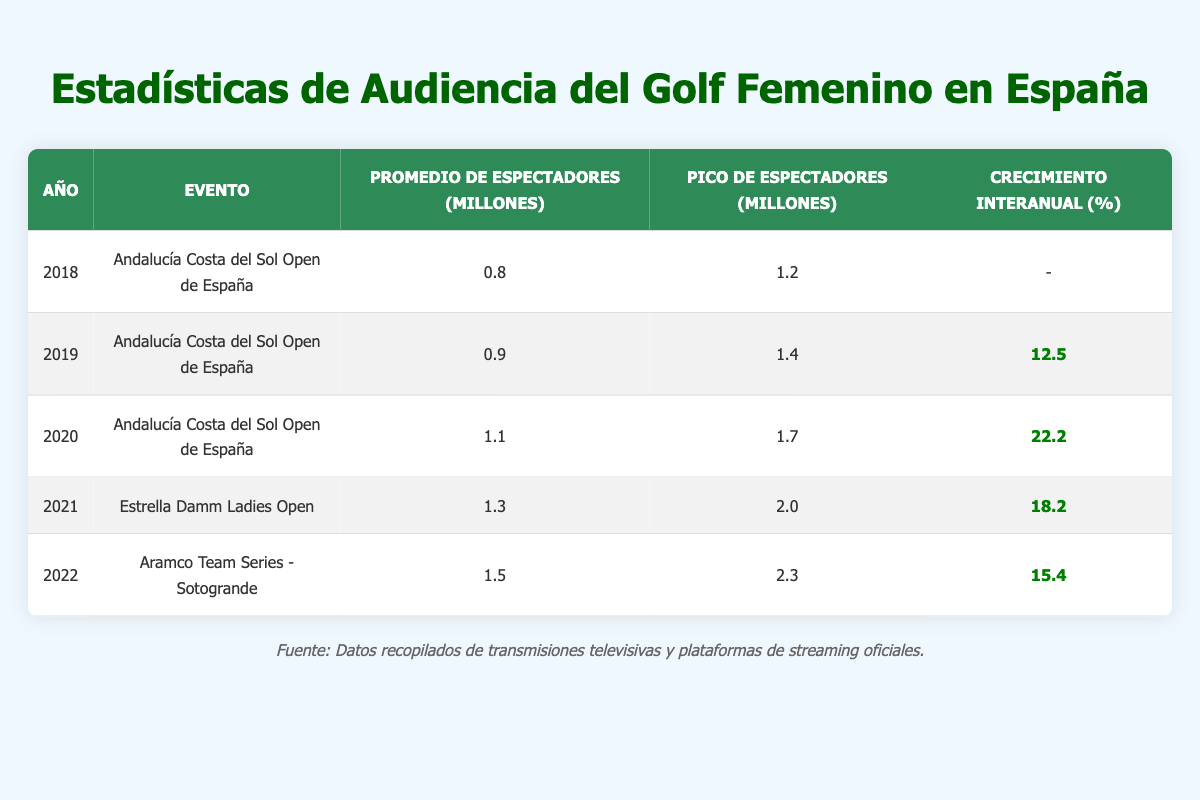What was the average viewership in 2022? The table shows that in 2022, the average viewers for the "Aramco Team Series - Sotogrande" was 1.5 million.
Answer: 1.5 million In which year did the "Estrella Damm Ladies Open" take place? According to the table, the "Estrella Damm Ladies Open" was held in 2021.
Answer: 2021 What was the year-on-year growth between 2020 and 2021? For 2020, the average viewers were 1.1 million and for 2021, it was 1.3 million. The year-on-year growth can be calculated as ((1.3 - 1.1) / 1.1) * 100 = 18.18%.
Answer: 18.2% Did the average viewership for women's golf events in Spain increase every year from 2018 to 2022? By checking the average viewers for each year: 0.8 in 2018, 0.9 in 2019, 1.1 in 2020, 1.3 in 2021, and 1.5 in 2022, we can confirm there is an increase every year.
Answer: Yes What is the total average viewership across all years in the table? To find the total average viewership, sum all averages: 0.8 + 0.9 + 1.1 + 1.3 + 1.5 = 5.6 million.
Answer: 5.6 million Which event had the highest peak viewership and what was that viewership? The peak viewership for the "Aramco Team Series - Sotogrande" in 2022 reached 2.3 million, which is the highest in the table.
Answer: 2.3 million What was the average viewership growth from 2019 to 2020? The average viewers increased from 0.9 million in 2019 to 1.1 million in 2020. The growth percentage is calculated as ((1.1 - 0.9) / 0.9) * 100 = 22.22%.
Answer: 22.2% Was the average viewership higher in the "Estrella Damm Ladies Open" than in the "Andalucía Costa del Sol Open de España" in 2021? In 2021, the "Estrella Damm Ladies Open" had an average viewership of 1.3 million, while the "Andalucía Costa del Sol Open de España" had 1.1 million in the previous year. So yes, it was higher.
Answer: Yes 